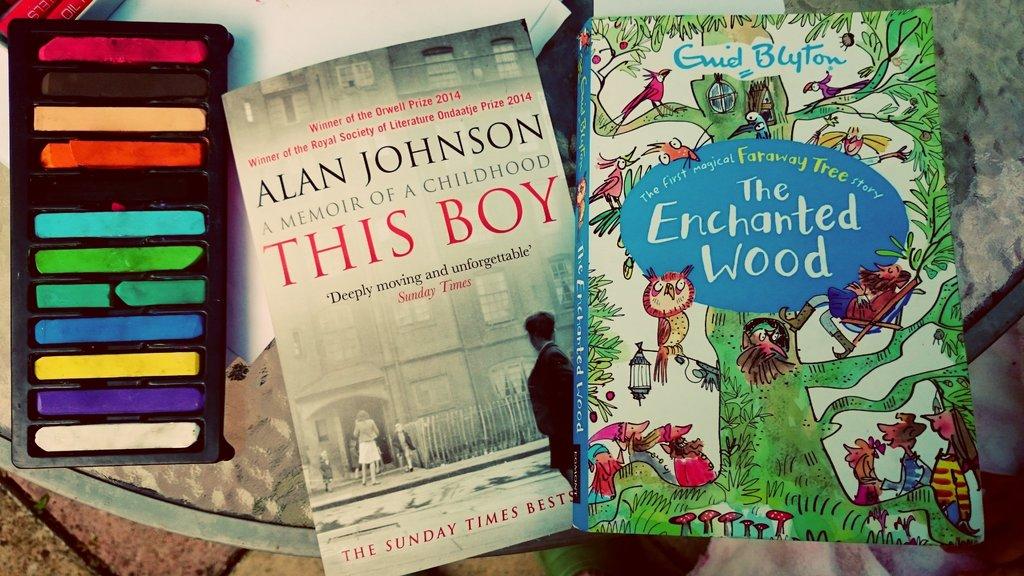What is this boy about?
Ensure brevity in your answer.  A memoir of a childhood. Who wrote this boy?
Keep it short and to the point. Alan johnson. 